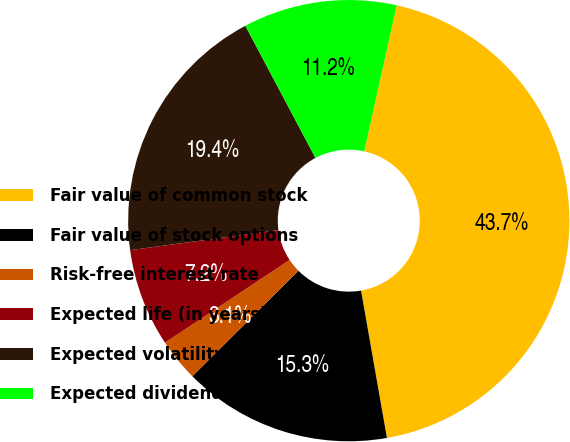Convert chart to OTSL. <chart><loc_0><loc_0><loc_500><loc_500><pie_chart><fcel>Fair value of common stock<fcel>Fair value of stock options<fcel>Risk-free interest rate<fcel>Expected life (in years)<fcel>Expected volatility<fcel>Expected dividend yield<nl><fcel>43.75%<fcel>15.31%<fcel>3.13%<fcel>7.19%<fcel>19.37%<fcel>11.25%<nl></chart> 